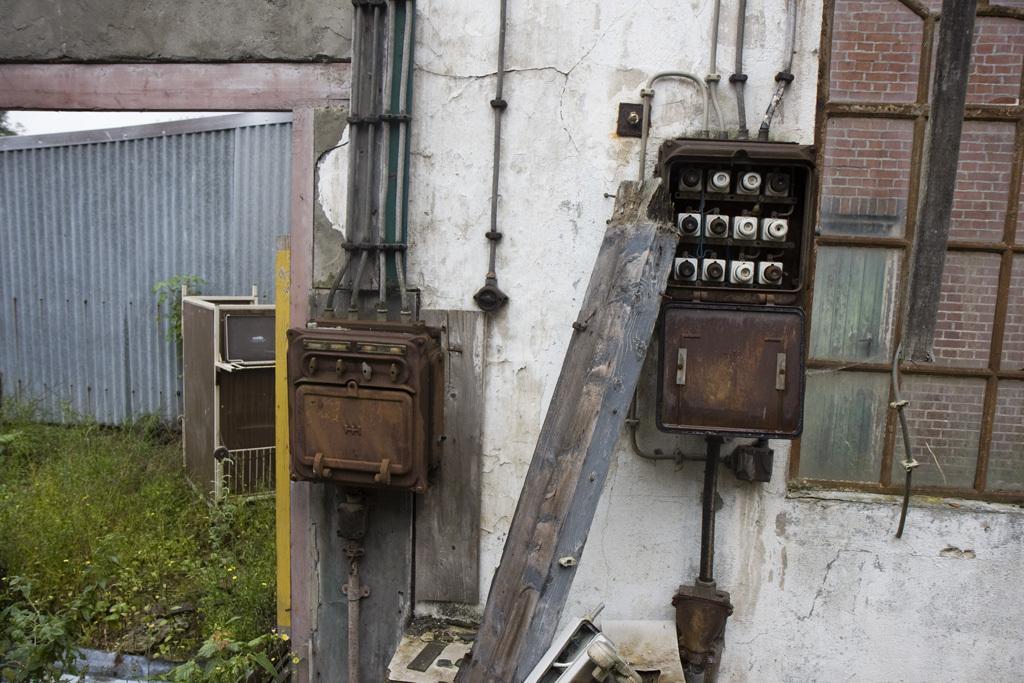Can you describe this image briefly? In this image I can see grass, wall, pipes, window and meter. This image is taken during a day. 